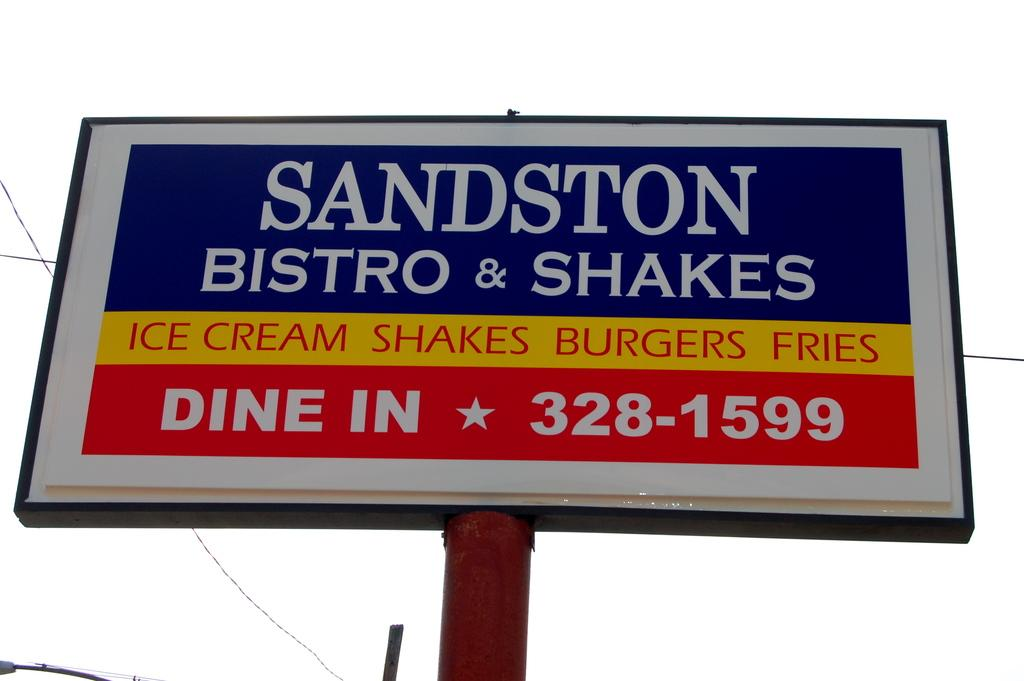Provide a one-sentence caption for the provided image. Large sign that says "Sandston Bistro & Shakes" towards the top. 